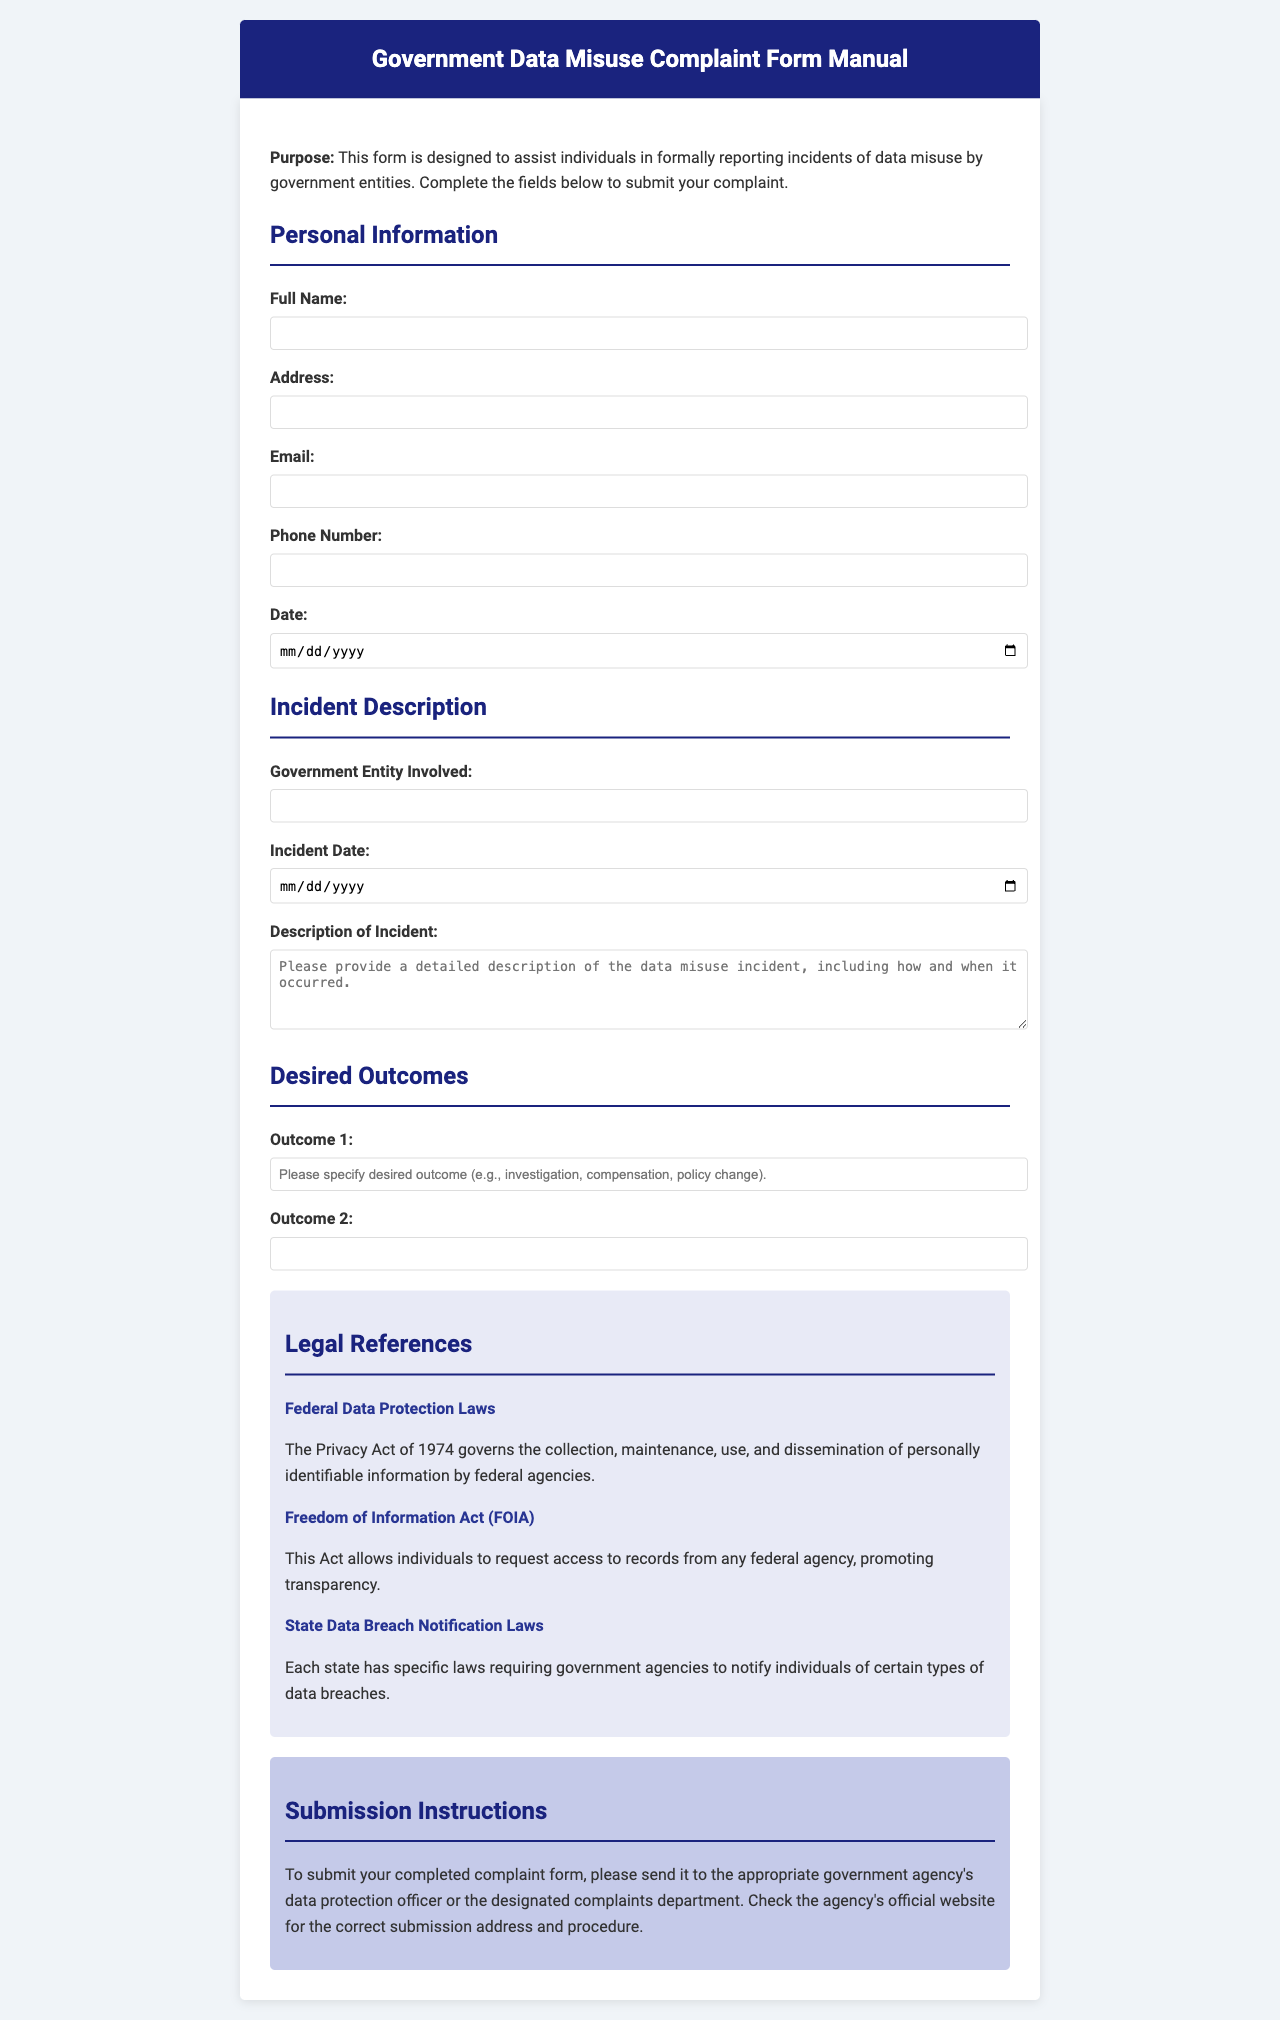What is the title of the document? The title of the document is specified in the header section of the HTML, which is "Government Data Misuse Complaint Form Manual."
Answer: Government Data Misuse Complaint Form Manual What is the purpose of the complaint form? The purpose is outlined in the first paragraph, which states it is designed to assist individuals in formally reporting incidents of data misuse by government entities.
Answer: To assist individuals in formally reporting incidents of data misuse by government entities How many outcomes can be specified in the form? The form includes fields for two outcomes under the Desired Outcomes section, indicating the possibility to specify two outcomes.
Answer: Two What is one of the legal references mentioned? The document lists several legal references; one is "The Privacy Act of 1974," which governs the use of personally identifiable information.
Answer: The Privacy Act of 1974 Where should the completed complaint form be sent? The submission instructions specify that the form should be sent to the appropriate government agency's data protection officer or the designated complaints department.
Answer: To the appropriate government agency's data protection officer or designated complaints department What type of information is collected in the Personal Information section? The Personal Information section collects details such as full name, address, email, and phone number.
Answer: Full name, address, email, and phone number What is the color of the header background? The header background color is defined in the style section, and it is specified as dark blue.
Answer: Dark blue Which Act allows individuals to request access to records from federal agencies? The Freedom of Information Act (FOIA) is specifically mentioned in the legal references as allowing individuals to request access to records.
Answer: Freedom of Information Act (FOIA) 